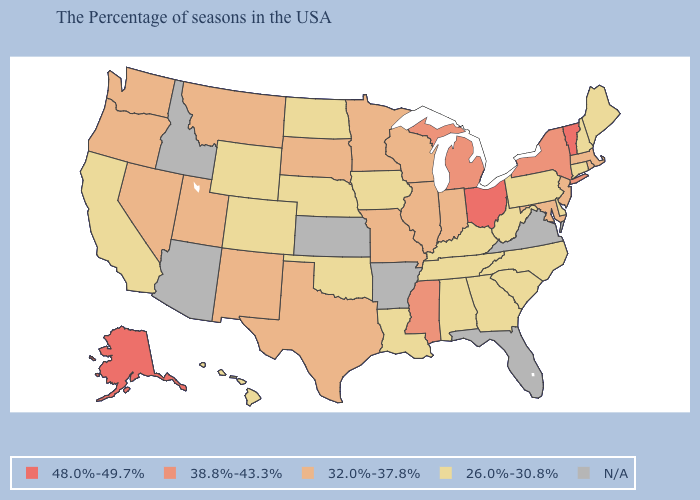Among the states that border Utah , which have the highest value?
Write a very short answer. New Mexico, Nevada. Among the states that border Connecticut , does Massachusetts have the lowest value?
Answer briefly. Yes. What is the value of New Mexico?
Be succinct. 32.0%-37.8%. What is the value of Alaska?
Short answer required. 48.0%-49.7%. Name the states that have a value in the range N/A?
Concise answer only. Virginia, Florida, Arkansas, Kansas, Arizona, Idaho. What is the lowest value in the South?
Give a very brief answer. 26.0%-30.8%. What is the value of Nevada?
Quick response, please. 32.0%-37.8%. What is the lowest value in the USA?
Short answer required. 26.0%-30.8%. What is the highest value in the Northeast ?
Answer briefly. 48.0%-49.7%. Which states hav the highest value in the South?
Concise answer only. Mississippi. What is the value of Maryland?
Be succinct. 32.0%-37.8%. Is the legend a continuous bar?
Give a very brief answer. No. Name the states that have a value in the range 48.0%-49.7%?
Short answer required. Vermont, Ohio, Alaska. What is the value of New Mexico?
Give a very brief answer. 32.0%-37.8%. Among the states that border Arkansas , does Louisiana have the highest value?
Be succinct. No. 